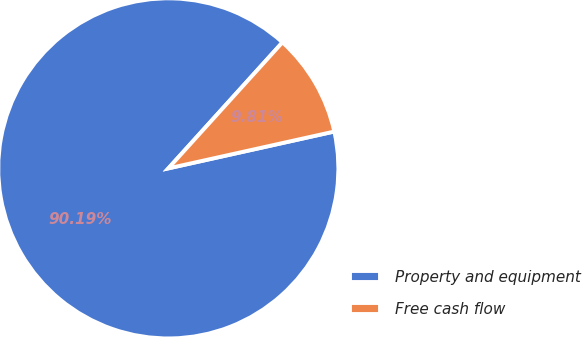<chart> <loc_0><loc_0><loc_500><loc_500><pie_chart><fcel>Property and equipment<fcel>Free cash flow<nl><fcel>90.19%<fcel>9.81%<nl></chart> 